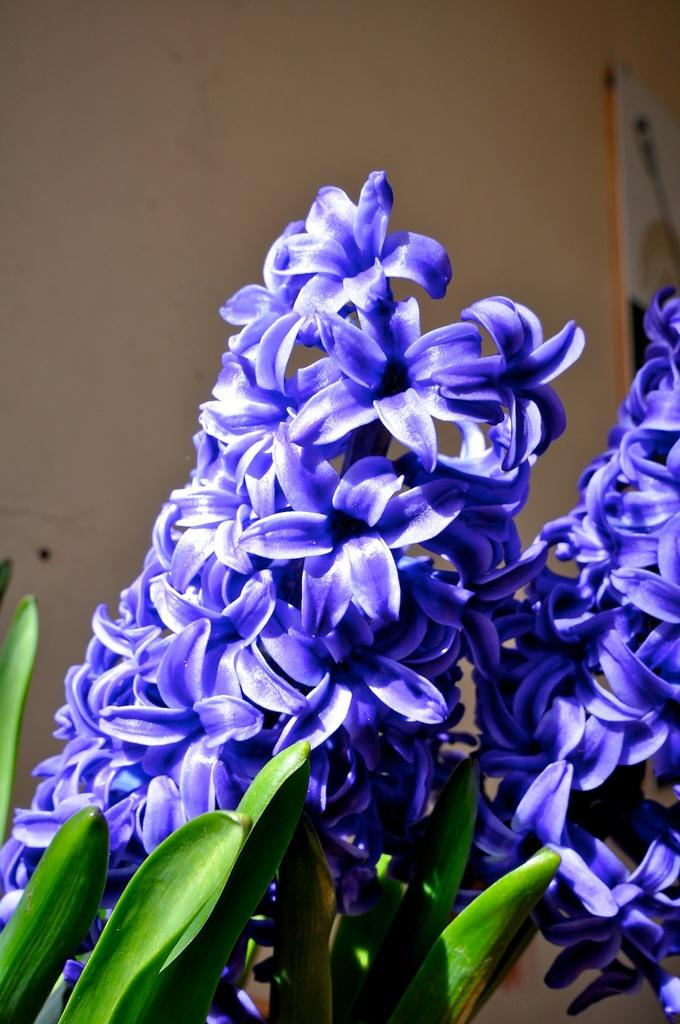What type of plants can be seen in the image? There are plants with flowers in the image. What color are the flowers on the plants? The flowers are in violet color. What can be seen in the background of the image? There is a white wall in the background of the image. How many pickles are hanging from the edge of the wall in the image? There are no pickles present in the image, and they are not hanging from the edge of the wall. 